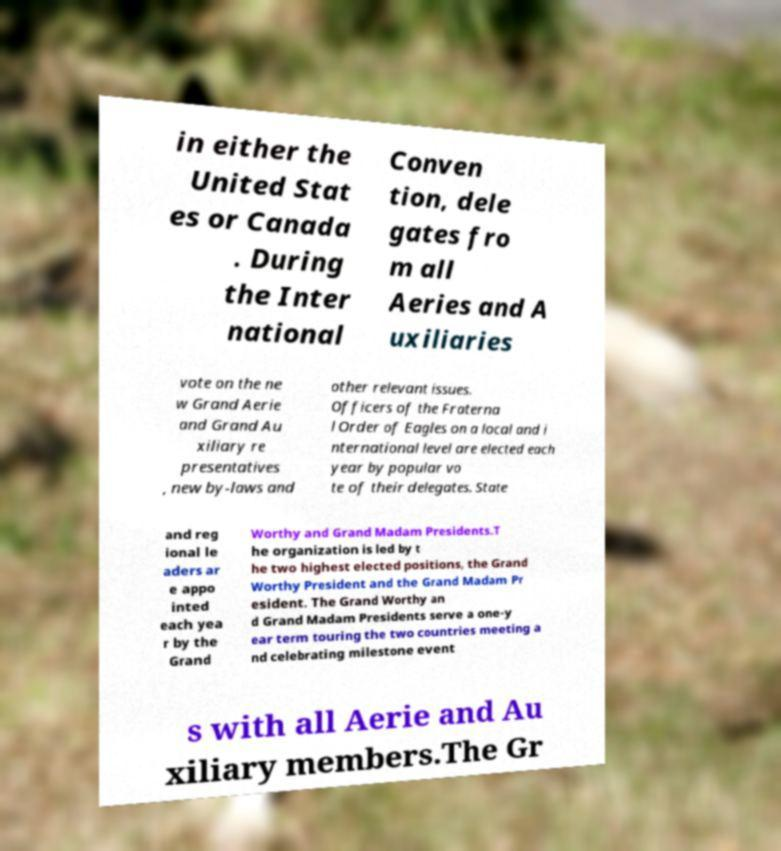What messages or text are displayed in this image? I need them in a readable, typed format. in either the United Stat es or Canada . During the Inter national Conven tion, dele gates fro m all Aeries and A uxiliaries vote on the ne w Grand Aerie and Grand Au xiliary re presentatives , new by-laws and other relevant issues. Officers of the Fraterna l Order of Eagles on a local and i nternational level are elected each year by popular vo te of their delegates. State and reg ional le aders ar e appo inted each yea r by the Grand Worthy and Grand Madam Presidents.T he organization is led by t he two highest elected positions, the Grand Worthy President and the Grand Madam Pr esident. The Grand Worthy an d Grand Madam Presidents serve a one-y ear term touring the two countries meeting a nd celebrating milestone event s with all Aerie and Au xiliary members.The Gr 